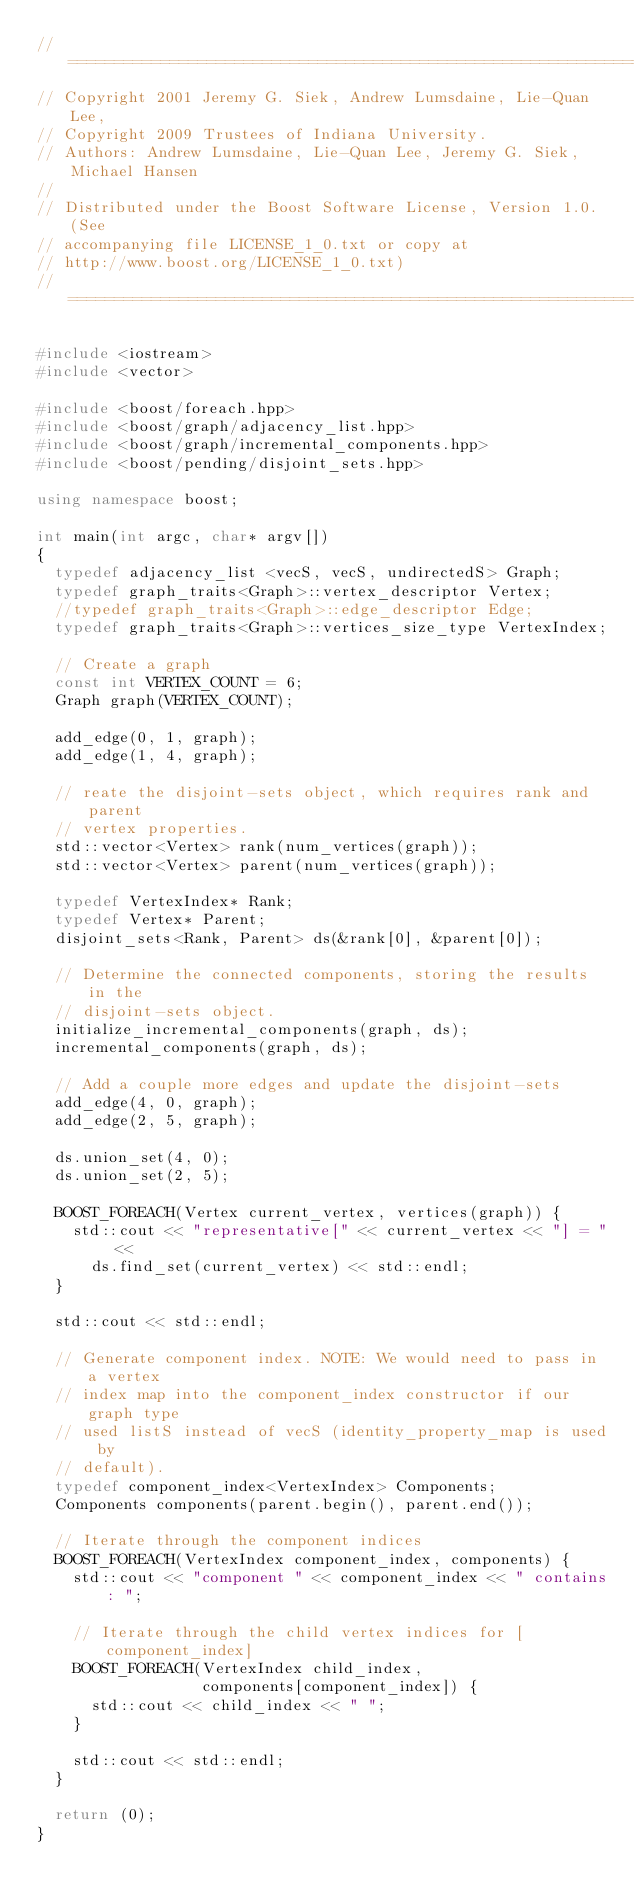Convert code to text. <code><loc_0><loc_0><loc_500><loc_500><_C++_>//=======================================================================
// Copyright 2001 Jeremy G. Siek, Andrew Lumsdaine, Lie-Quan Lee,
// Copyright 2009 Trustees of Indiana University.
// Authors: Andrew Lumsdaine, Lie-Quan Lee, Jeremy G. Siek, Michael Hansen
//
// Distributed under the Boost Software License, Version 1.0. (See
// accompanying file LICENSE_1_0.txt or copy at
// http://www.boost.org/LICENSE_1_0.txt)
//=======================================================================

#include <iostream>
#include <vector>

#include <boost/foreach.hpp>
#include <boost/graph/adjacency_list.hpp>
#include <boost/graph/incremental_components.hpp>
#include <boost/pending/disjoint_sets.hpp>

using namespace boost;

int main(int argc, char* argv[])
{
  typedef adjacency_list <vecS, vecS, undirectedS> Graph;
  typedef graph_traits<Graph>::vertex_descriptor Vertex;
  //typedef graph_traits<Graph>::edge_descriptor Edge;
  typedef graph_traits<Graph>::vertices_size_type VertexIndex;

  // Create a graph
  const int VERTEX_COUNT = 6;
  Graph graph(VERTEX_COUNT);

  add_edge(0, 1, graph);
  add_edge(1, 4, graph);

  // reate the disjoint-sets object, which requires rank and parent
  // vertex properties.
  std::vector<Vertex> rank(num_vertices(graph));
  std::vector<Vertex> parent(num_vertices(graph));

  typedef VertexIndex* Rank;
  typedef Vertex* Parent;
  disjoint_sets<Rank, Parent> ds(&rank[0], &parent[0]);

  // Determine the connected components, storing the results in the
  // disjoint-sets object.
  initialize_incremental_components(graph, ds);
  incremental_components(graph, ds);

  // Add a couple more edges and update the disjoint-sets
  add_edge(4, 0, graph);
  add_edge(2, 5, graph);

  ds.union_set(4, 0);
  ds.union_set(2, 5);

  BOOST_FOREACH(Vertex current_vertex, vertices(graph)) {
    std::cout << "representative[" << current_vertex << "] = " <<
      ds.find_set(current_vertex) << std::endl;
  }

  std::cout << std::endl;

  // Generate component index. NOTE: We would need to pass in a vertex
  // index map into the component_index constructor if our graph type
  // used listS instead of vecS (identity_property_map is used by
  // default).
  typedef component_index<VertexIndex> Components;
  Components components(parent.begin(), parent.end());

  // Iterate through the component indices
  BOOST_FOREACH(VertexIndex component_index, components) {
    std::cout << "component " << component_index << " contains: ";

    // Iterate through the child vertex indices for [component_index]
    BOOST_FOREACH(VertexIndex child_index,
                  components[component_index]) {
      std::cout << child_index << " ";
    }

    std::cout << std::endl;
  }

  return (0);
}
</code> 